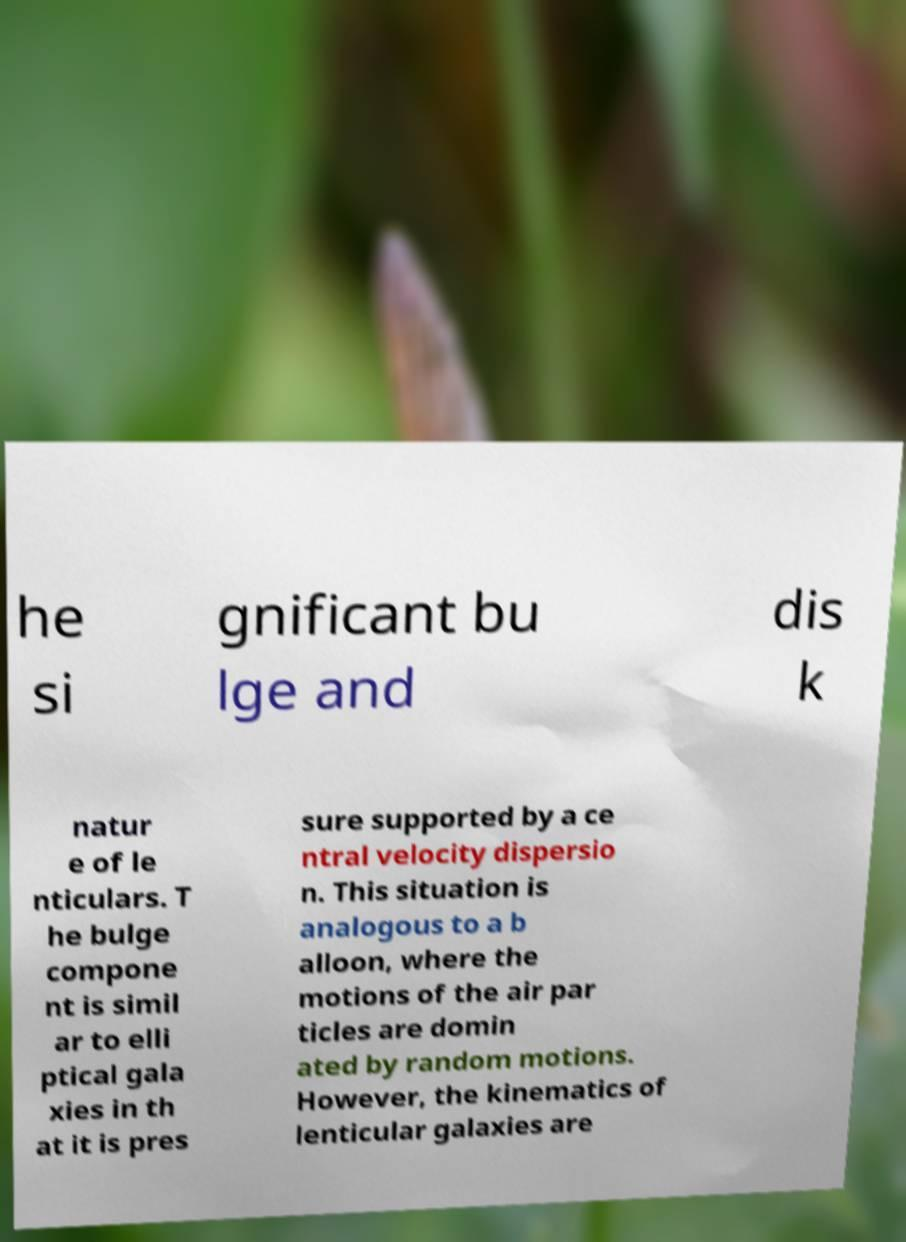Can you accurately transcribe the text from the provided image for me? he si gnificant bu lge and dis k natur e of le nticulars. T he bulge compone nt is simil ar to elli ptical gala xies in th at it is pres sure supported by a ce ntral velocity dispersio n. This situation is analogous to a b alloon, where the motions of the air par ticles are domin ated by random motions. However, the kinematics of lenticular galaxies are 